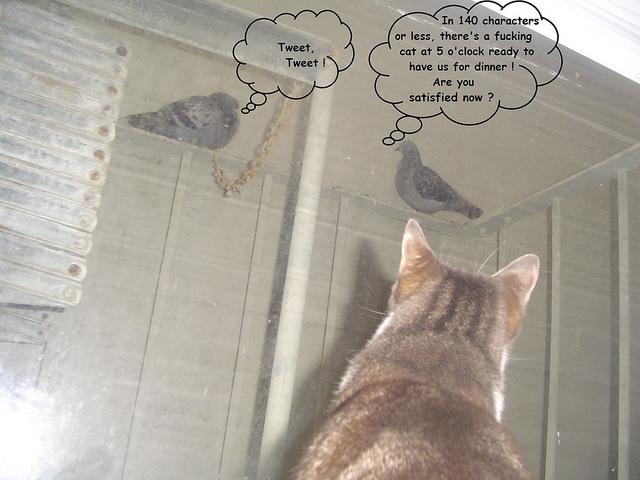How many birds does the cat see?
Answer briefly. 2. What is the explicit language written on the picture?
Answer briefly. Fucking. What does the bubble on the left say?
Keep it brief. Tweet. 